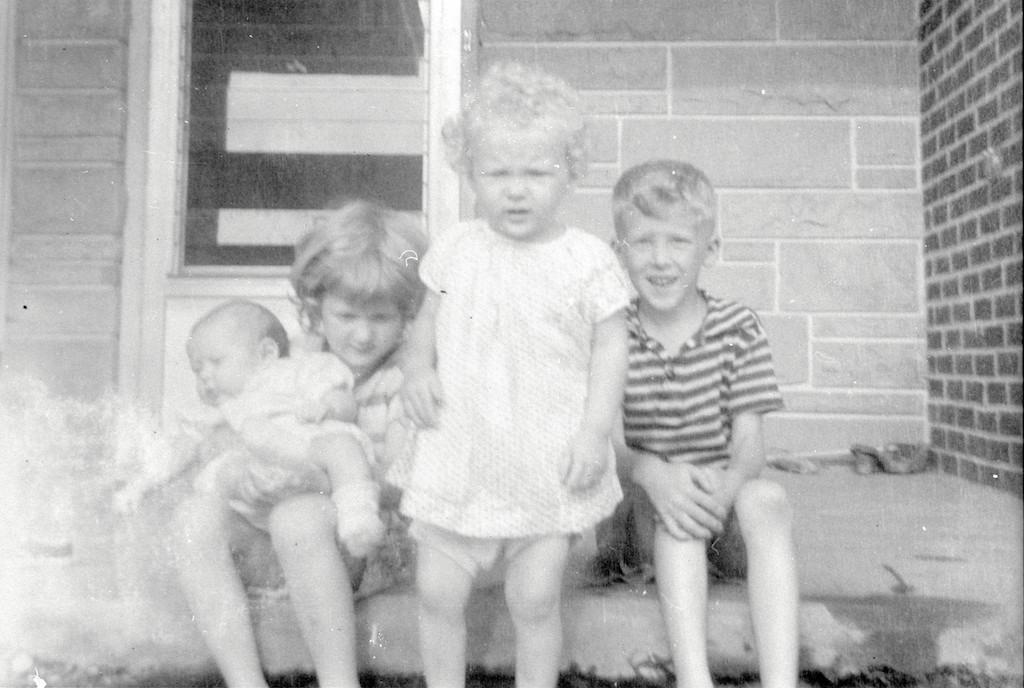How many kids are sitting on the ground in the image? There are two kids sitting on the ground in the image. What is the position of the third kid in the image? There is a kid standing in the middle of the image. Can you describe the interaction between the kids? A baby is in the lap of a kid sitting on the left. What can be seen in the background of the image? There is a building in the background of the image. What type of belief system is being practiced by the kids in the image? There is no indication of any belief system being practiced in the image; it simply shows kids sitting and standing. Can you provide a receipt for the items in the image? There are no items in the image that would require a receipt, as it only shows kids in various positions. 